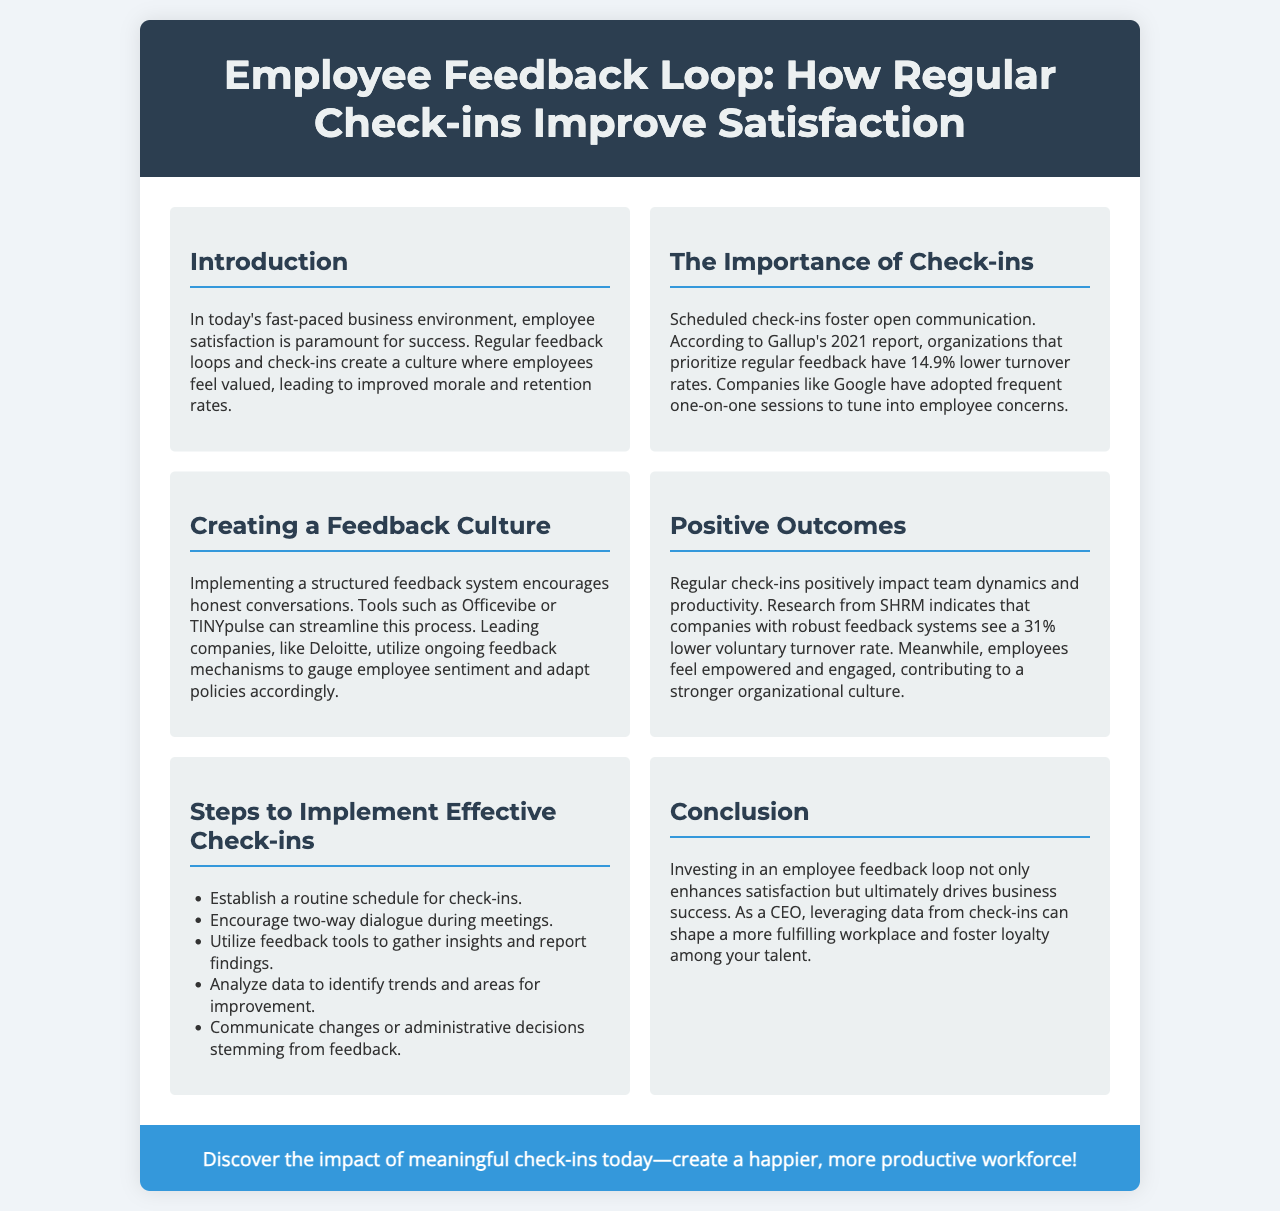What is the title of the brochure? The title is given prominently at the top of the document.
Answer: Employee Feedback Loop: How Regular Check-ins Improve Satisfaction What percentage lower is the turnover rate for organizations that prioritize regular feedback? This statistic is mentioned in the "The Importance of Check-ins" section.
Answer: 14.9% Which companies are mentioned as examples for adopting frequent check-ins? The brochure cites specific companies that utilize this method.
Answer: Google What research indicates a 31% lower voluntary turnover rate? This statistic comes from a certain organization's study referenced in the document.
Answer: SHRM What tools are suggested for implementing a structured feedback system? The document lists specific tools for fostering feedback culture.
Answer: Officevibe or TINYpulse What is one of the steps to implement effective check-ins? This question pertains to the practical advice given in the document.
Answer: Establish a routine schedule for check-ins What does investing in an employee feedback loop enhance? The conclusion summarizes the benefits mentioned in the brochure.
Answer: Satisfaction What type of dialogue is encouraged during meetings? The document outlines the expected communication approach during check-ins.
Answer: Two-way dialogue 